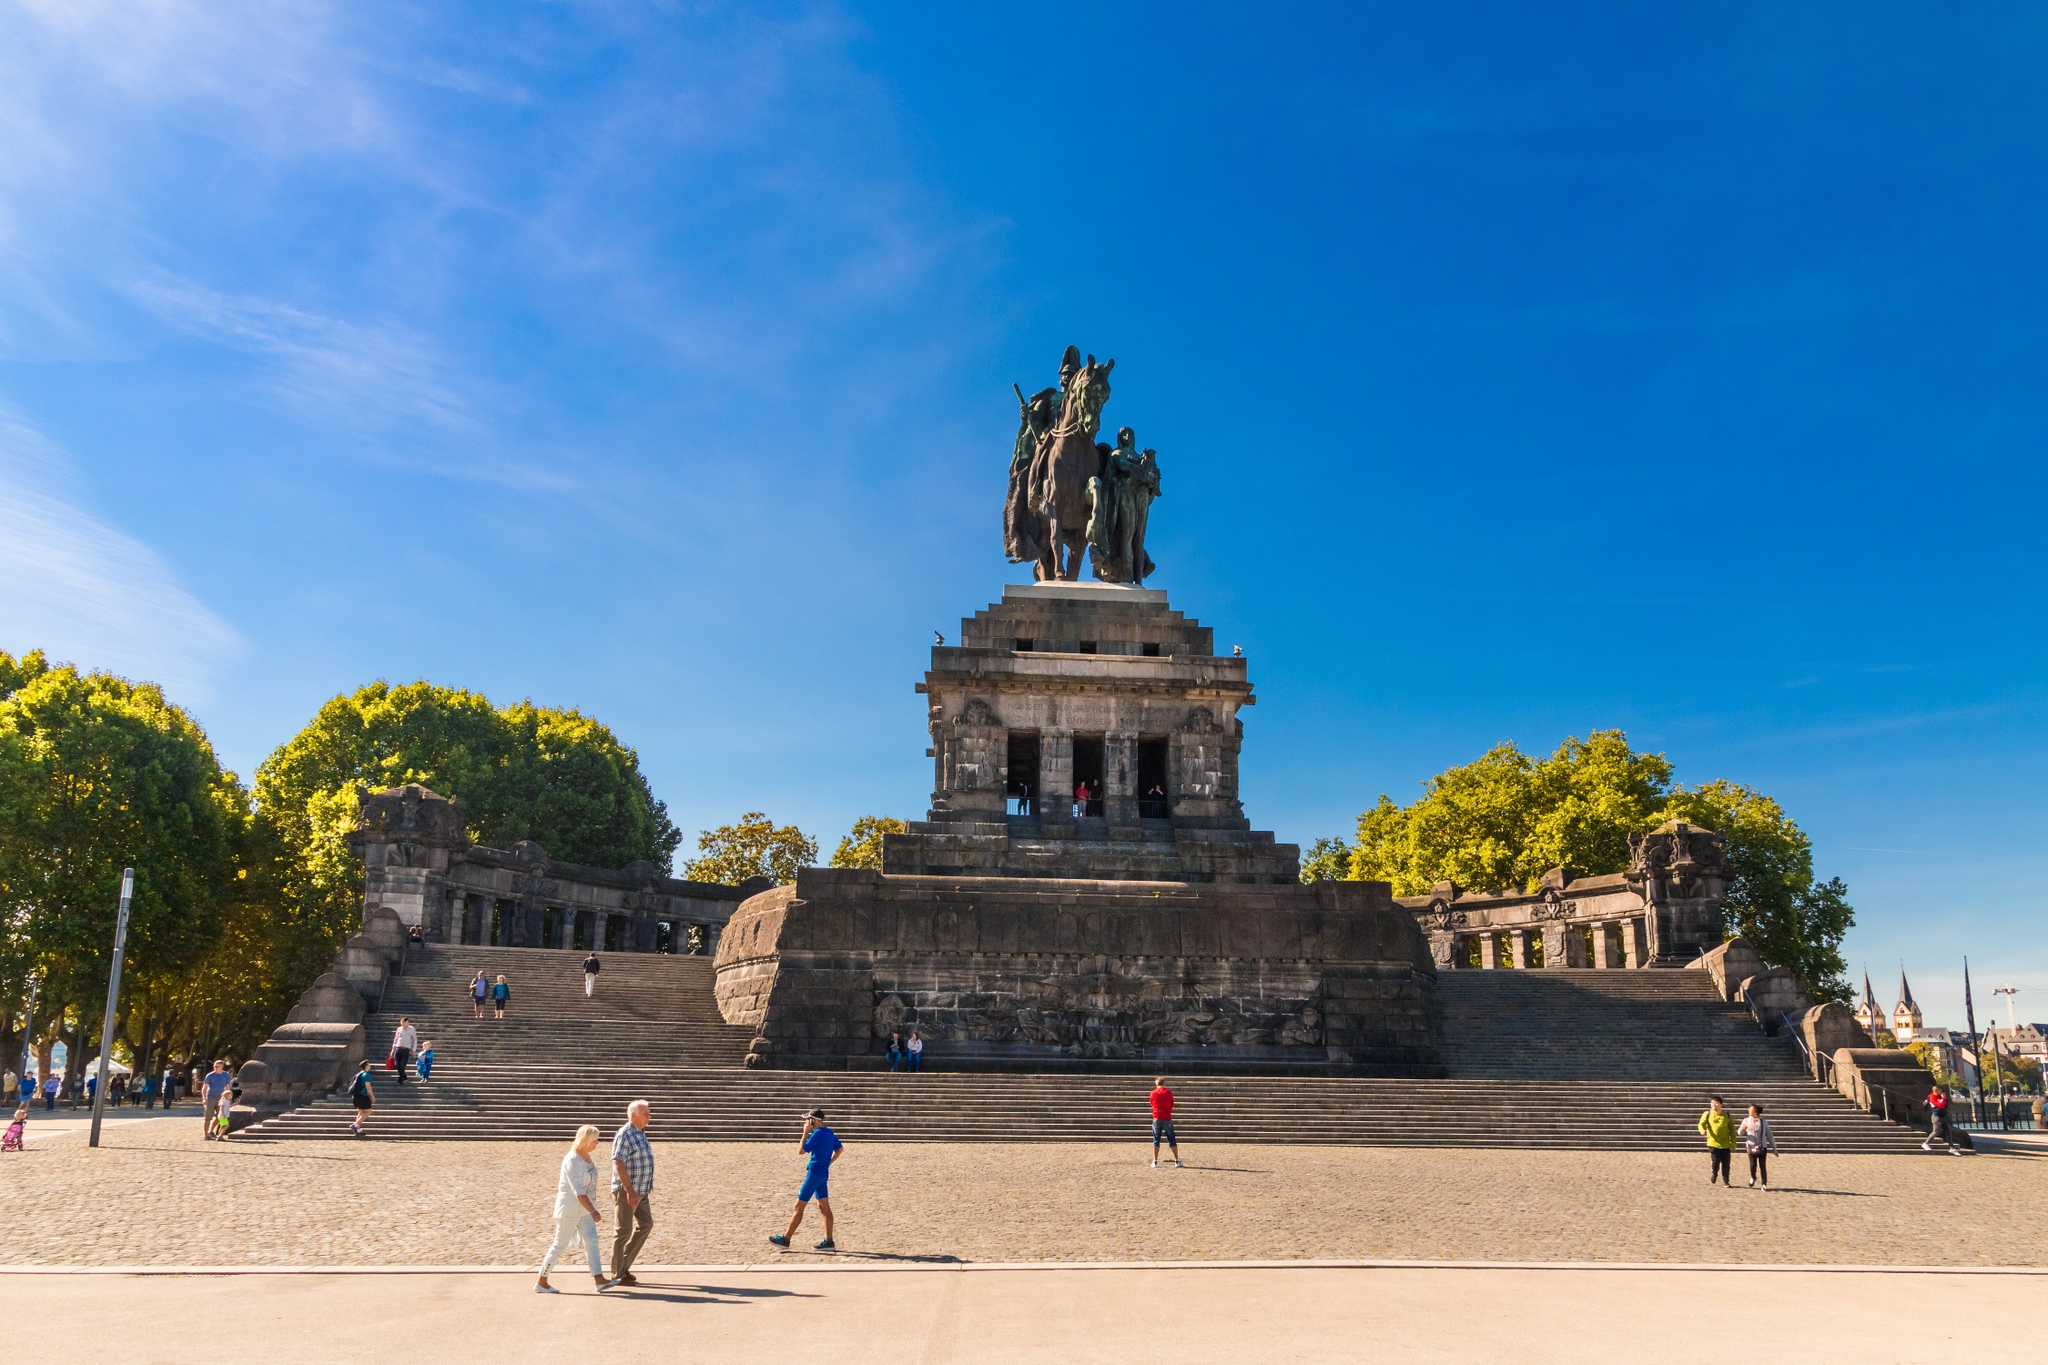What could be happening at Deutsches Eck on a busy summer afternoon? On a busy summer afternoon, Deutsches Eck would be bustling with activity. Tourists would be eagerly snapping pictures of the monumental statue, children might be running up and down the steps, their laughter ringing through the air. Local street vendors could be selling snacks and souvenirs, adding color and vibrancy to the scene. Meanwhile, history enthusiasts might be engaged in animated discussions about the significance of the location, and families could be enjoying picnics under the shade of nearby trees. The juxtaposition of history and the present makes Deutsches Eck a living tapestry of German culture. The monument could serve as the centerpiece for a grand outdoor concert, with music filling the air and people gathered to celebrate a special occasion or festival, the historic setting adding a majestic backdrop to modern festivities. 